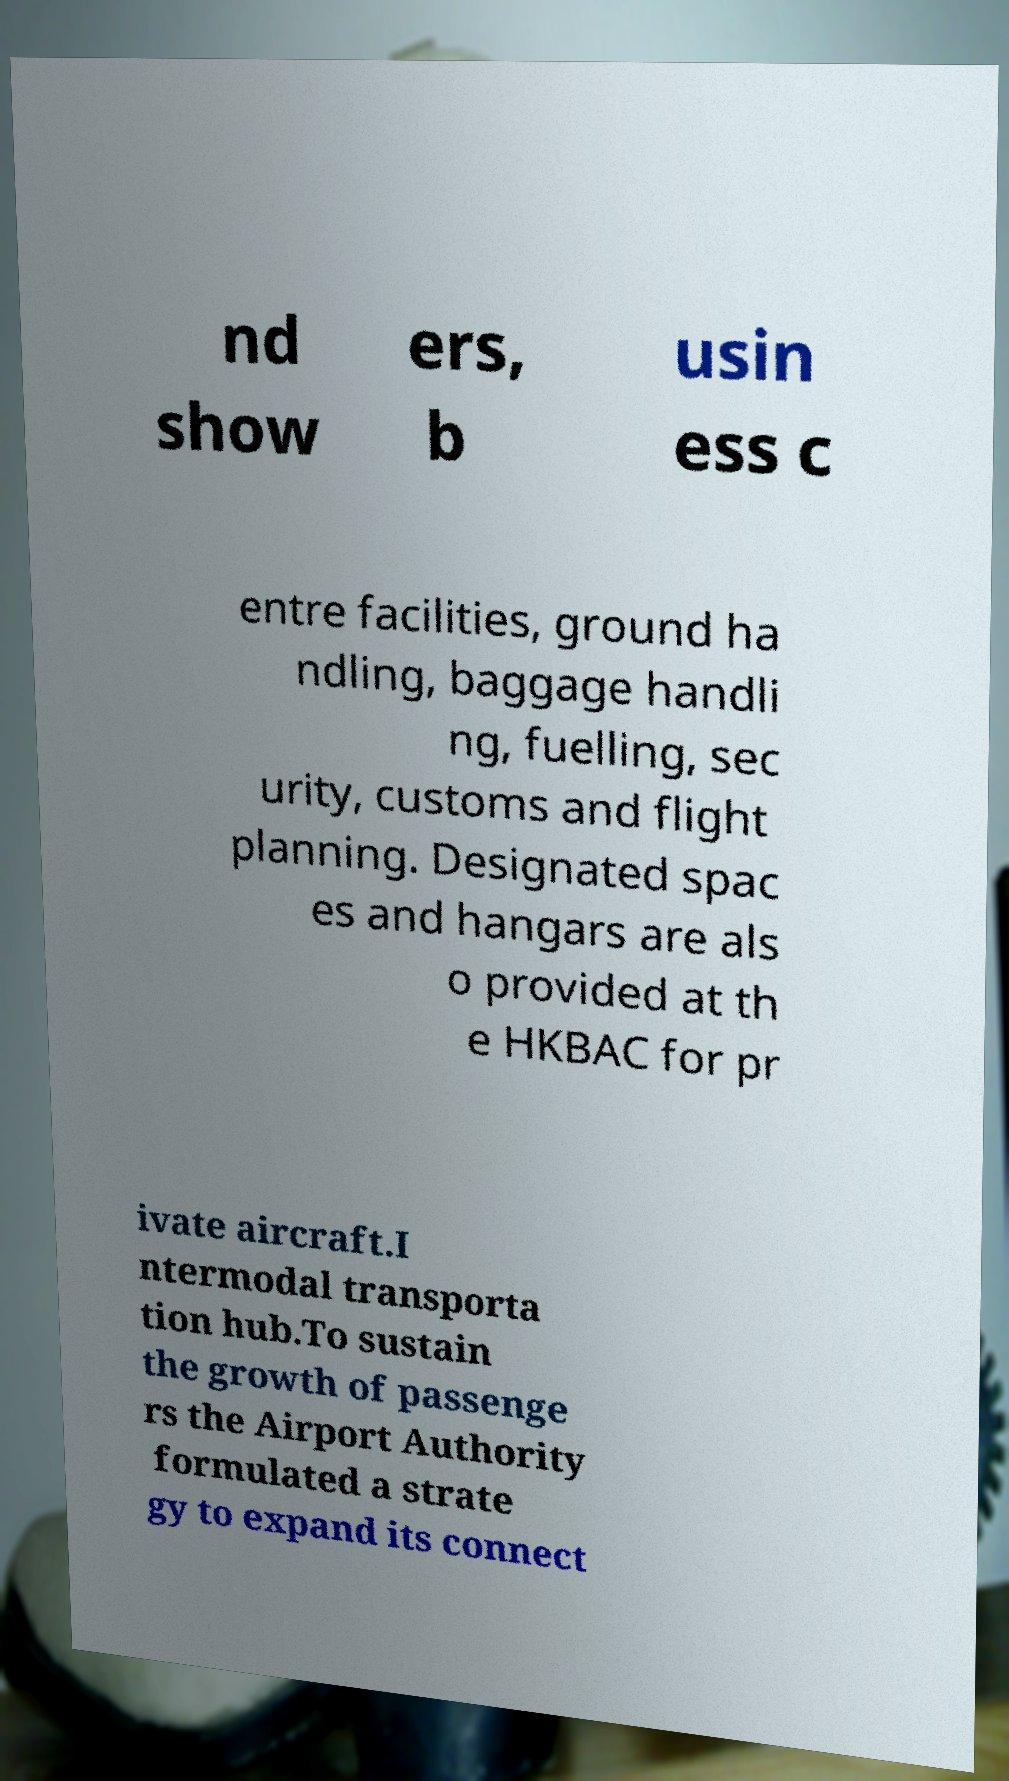I need the written content from this picture converted into text. Can you do that? nd show ers, b usin ess c entre facilities, ground ha ndling, baggage handli ng, fuelling, sec urity, customs and flight planning. Designated spac es and hangars are als o provided at th e HKBAC for pr ivate aircraft.I ntermodal transporta tion hub.To sustain the growth of passenge rs the Airport Authority formulated a strate gy to expand its connect 